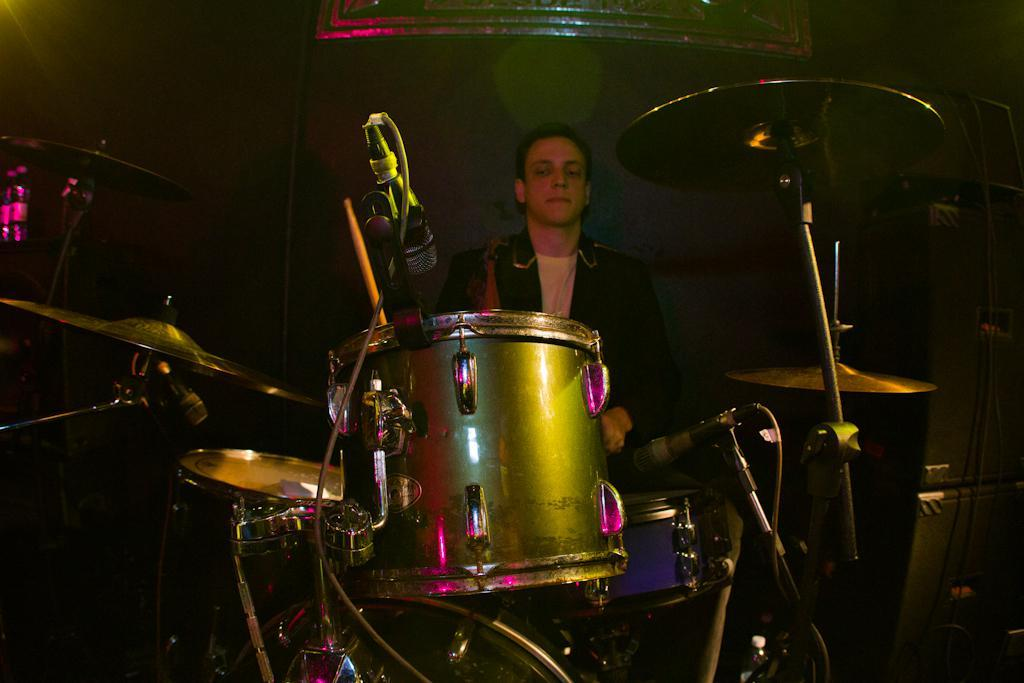What is the person in the image doing? The person is sitting in the image. What is the person wearing? The person is wearing clothes. What other objects are present in the image? There are musical instruments and a microphone in the image. Is there any equipment related to sound or recording in the image? Yes, there is a cable wire in the image. What time of day is it in the image? The time of day cannot be determined from the image, as there are no clues or indications of the time. 